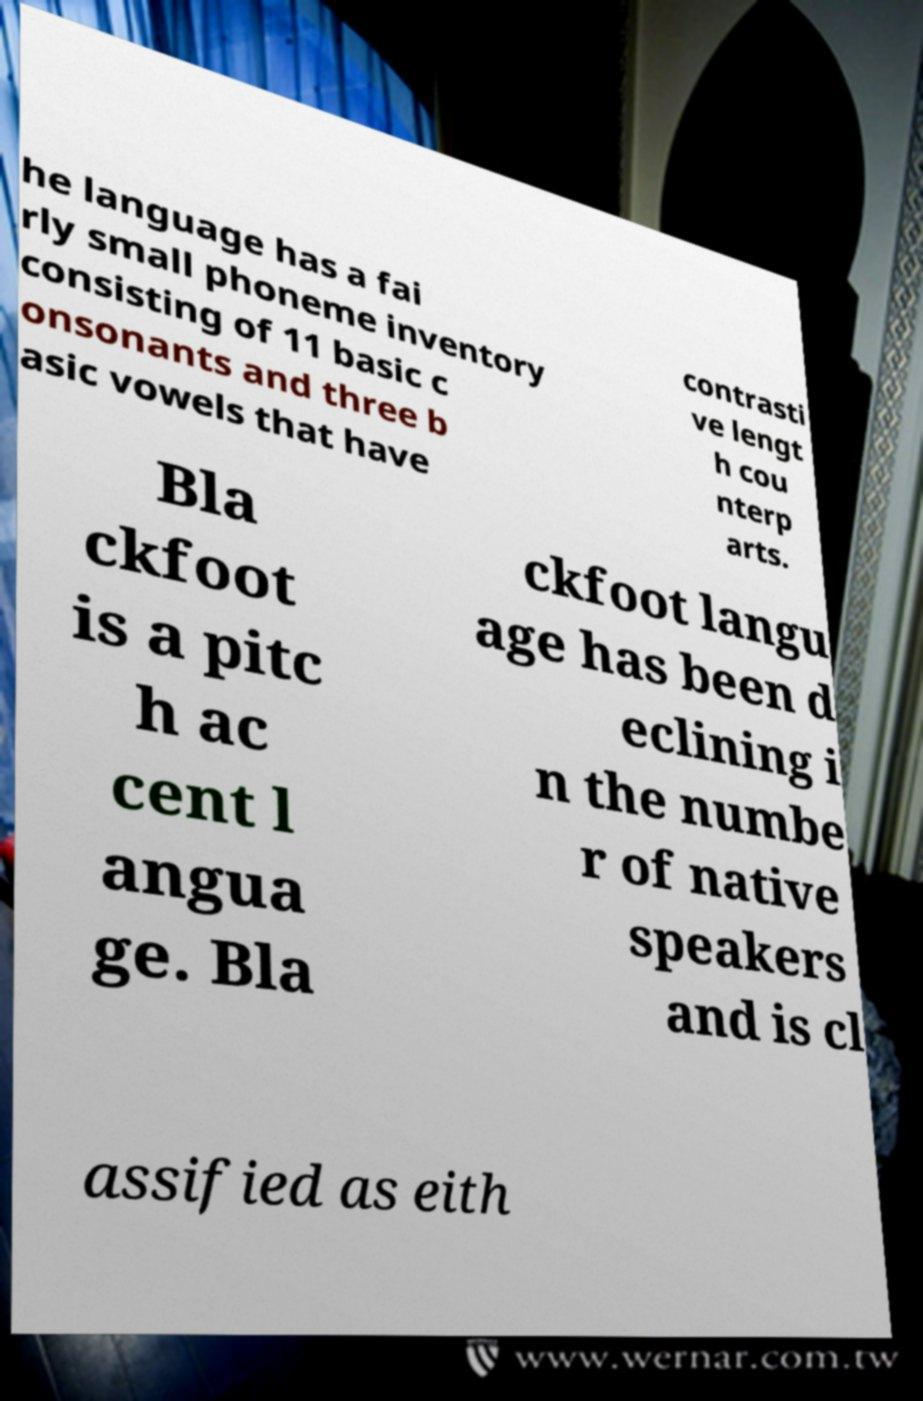Could you assist in decoding the text presented in this image and type it out clearly? he language has a fai rly small phoneme inventory consisting of 11 basic c onsonants and three b asic vowels that have contrasti ve lengt h cou nterp arts. Bla ckfoot is a pitc h ac cent l angua ge. Bla ckfoot langu age has been d eclining i n the numbe r of native speakers and is cl assified as eith 